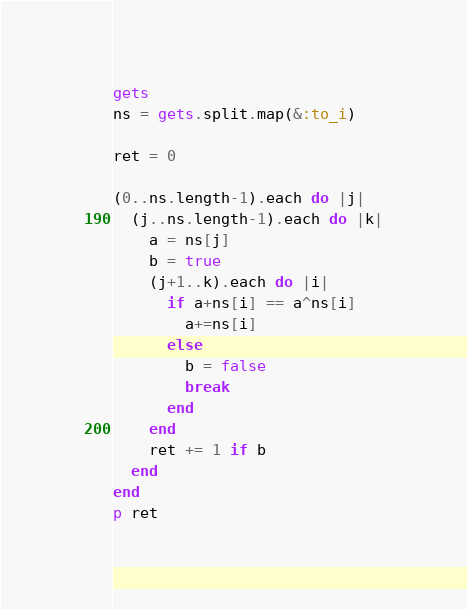Convert code to text. <code><loc_0><loc_0><loc_500><loc_500><_Ruby_>gets
ns = gets.split.map(&:to_i)

ret = 0

(0..ns.length-1).each do |j|
  (j..ns.length-1).each do |k|
    a = ns[j]
    b = true
    (j+1..k).each do |i|
      if a+ns[i] == a^ns[i]
        a+=ns[i]
      else
        b = false
        break
      end
    end
    ret += 1 if b
  end
end
p ret</code> 